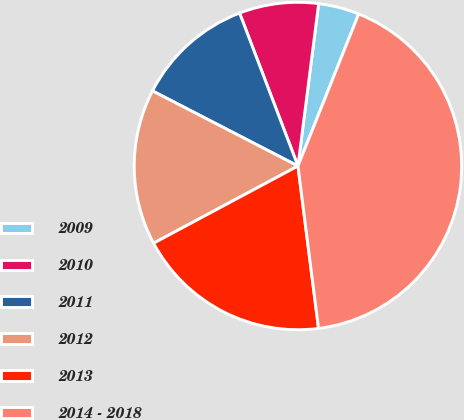Convert chart to OTSL. <chart><loc_0><loc_0><loc_500><loc_500><pie_chart><fcel>2009<fcel>2010<fcel>2011<fcel>2012<fcel>2013<fcel>2014 - 2018<nl><fcel>4.03%<fcel>7.82%<fcel>11.61%<fcel>15.4%<fcel>19.19%<fcel>41.94%<nl></chart> 